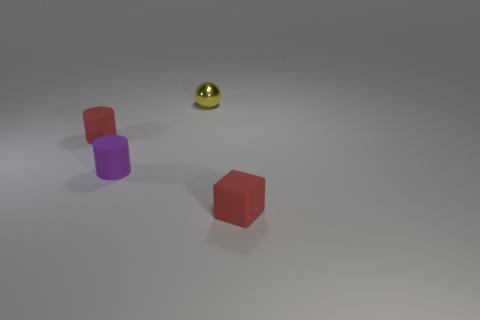Do the tiny object that is behind the tiny red cylinder and the rubber cylinder in front of the red rubber cylinder have the same color? Upon examining the image, it appears that the tiny object behind the red cylinder is a golden sphere, while the rubber cylinder in front of the red one is purple. So, the two objects mentioned do not share the same color; the sphere is golden and the cylinder in the front is purple. 